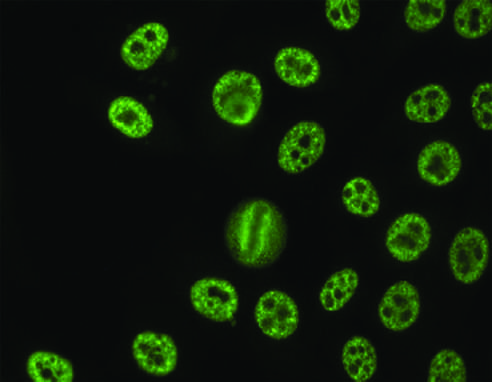s immunoperoxidase staining seen with antibodies against various nuclear antigens, including sm and rnps?
Answer the question using a single word or phrase. No 